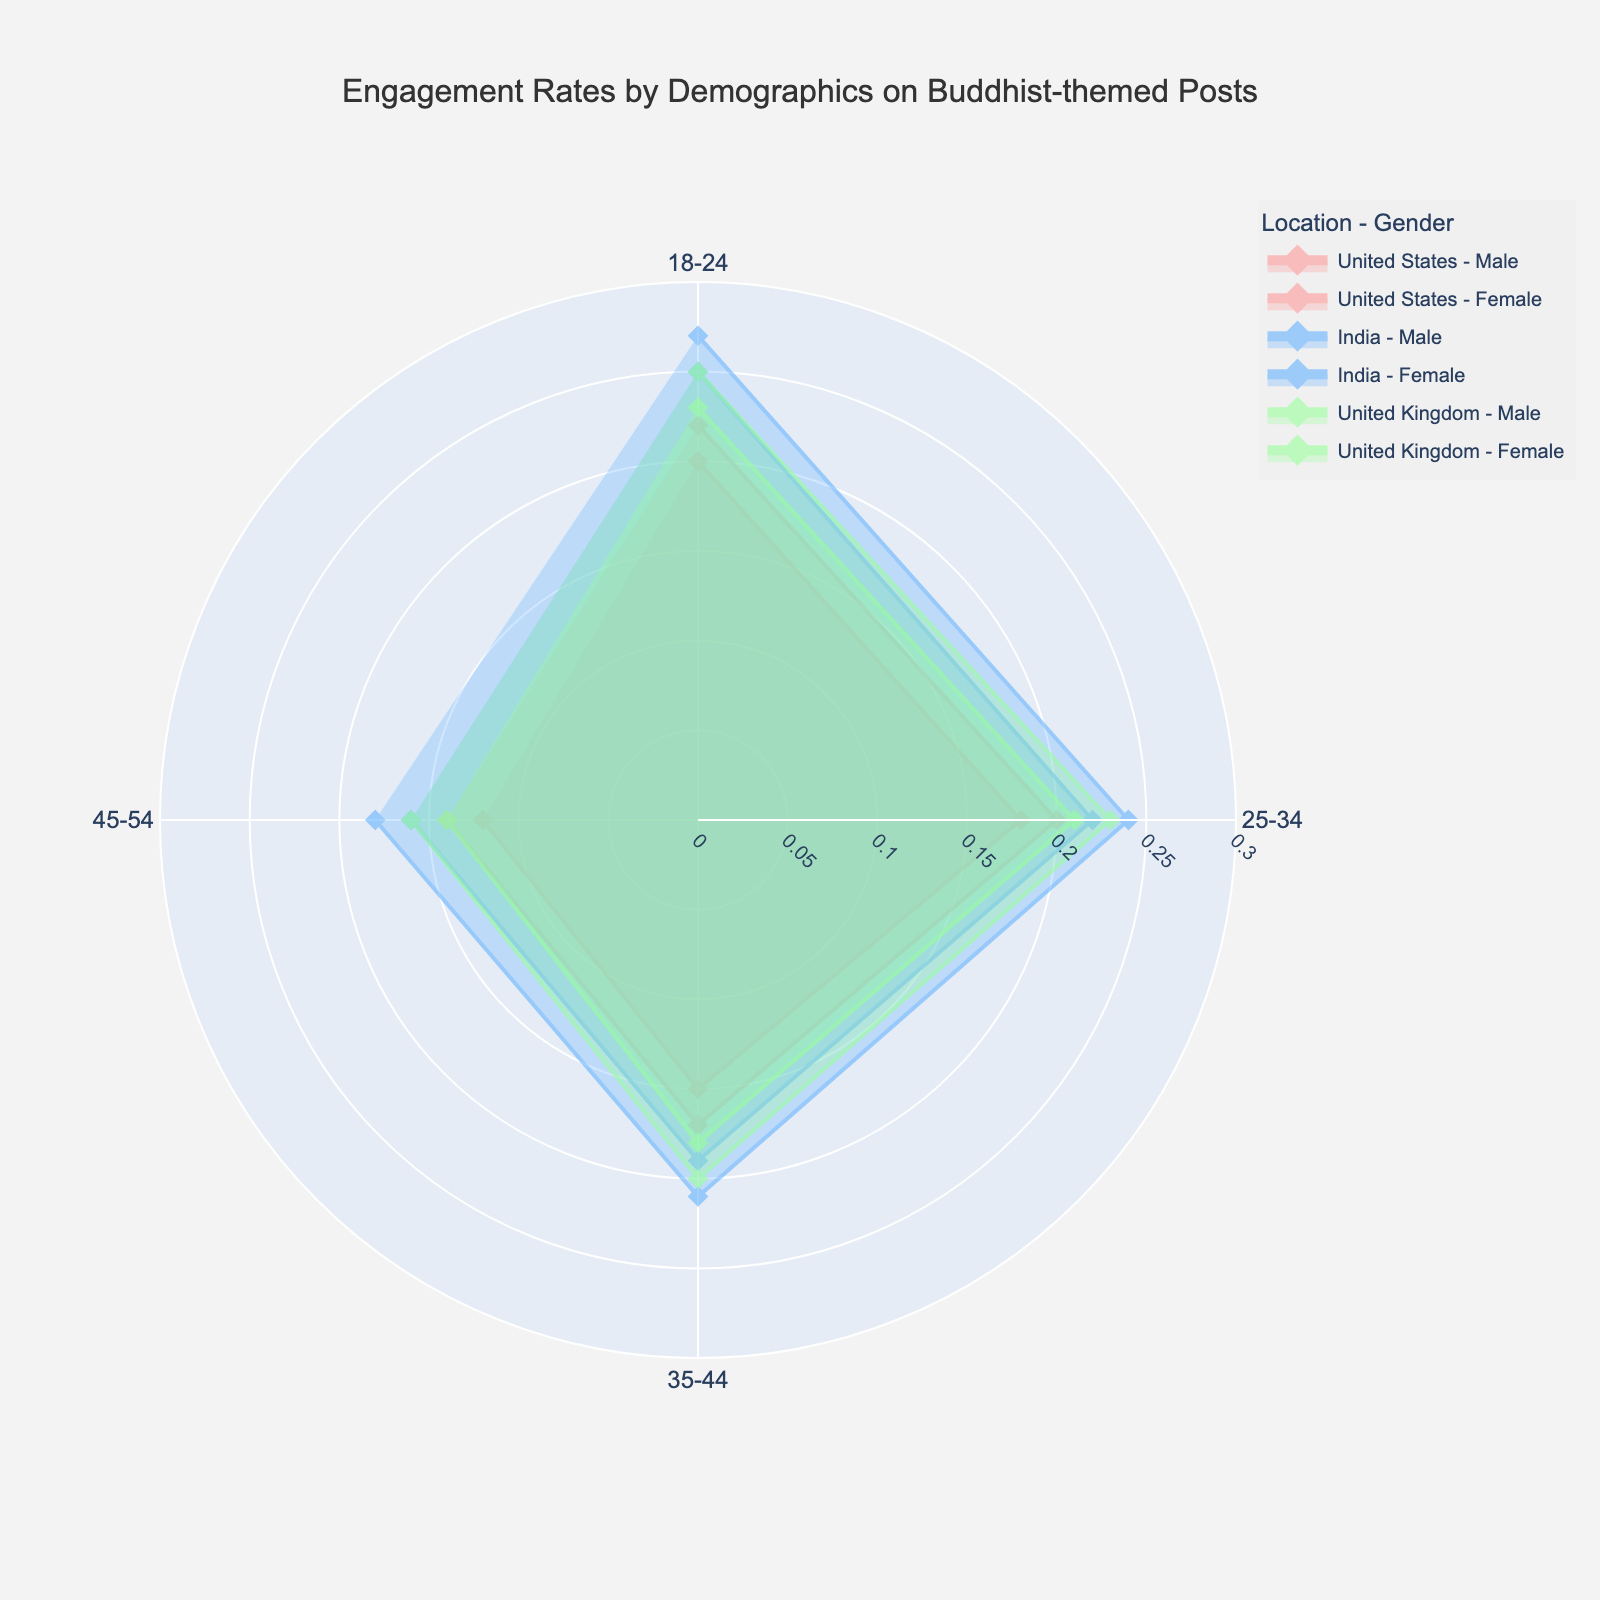What is the title of the figure? The title is displayed at the top of the redered figure. It states the main purpose or content of the plot.
Answer: Engagement Rates by Demographics on Buddhist-themed Posts What age group has the highest engagement rate for females in India? We need to look at the India - Female trace on the polar chart. The highest engagement rate for females in India is at age group 18-24.
Answer: 18-24 Which location-gender pair has the lowest engagement rate? We need to check the lowest radial value across all location-gender combinations. The lowest engagement rate is for Males aged 45-54 in the United States.
Answer: United States - Male How does the engagement rate for females aged 25-34 in the United Kingdom compare to the same demographic in India? Find the engagement rates for females aged 25-34 in both locations and compare them: United Kingdom (0.23) and India (0.24). The engagement rate in India is 0.01 higher.
Answer: 0.01 higher in India What is the range of engagement rates for all age groups in the United States? Identify the minimum and maximum engagement rates in the United States for all age groups. The range is from 0.12 (Male 45-54) to 0.22 (Female 18-24). So, the range is 0.22 - 0.12 = 0.10.
Answer: 0.10 Which age group shows a consistent increase in engagement rates across all locations and genders? Examine engagement rates for each age group in all locations and genders. For age group 35-44, all engagement rates increase consistently across all genders and locations.
Answer: 35-44 Which location has the highest average engagement rate across all demographics? Calculate the average engagement rate for each location by summing engagement rates across all age groups and genders, then dividing by the total number of groups. India has the highest average engagement rate: (0.25+0.27+0.22+0.24+0.19+0.21+0.16+0.18)/8 ≈ 0.2163.
Answer: India What is the engagement rate for males aged 18-24 in both the United Kingdom and the United States? Look at the radial values for males aged 18-24 in both locations. In the United Kingdom it is 0.23 and in the United States it is 0.20.
Answer: 0.23 in the United Kingdom, 0.20 in the United States How do engagement rates for females aged 35-44 in the United States compare to those in the United Kingdom? Compare the radial values for females aged 35-44 in both locations. United States has an engagement rate of 0.17, while the United Kingdom has 0.20.
Answer: 0.17 in the United States, 0.20 in the United Kingdom 